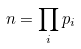Convert formula to latex. <formula><loc_0><loc_0><loc_500><loc_500>n = \prod _ { i } p _ { i }</formula> 